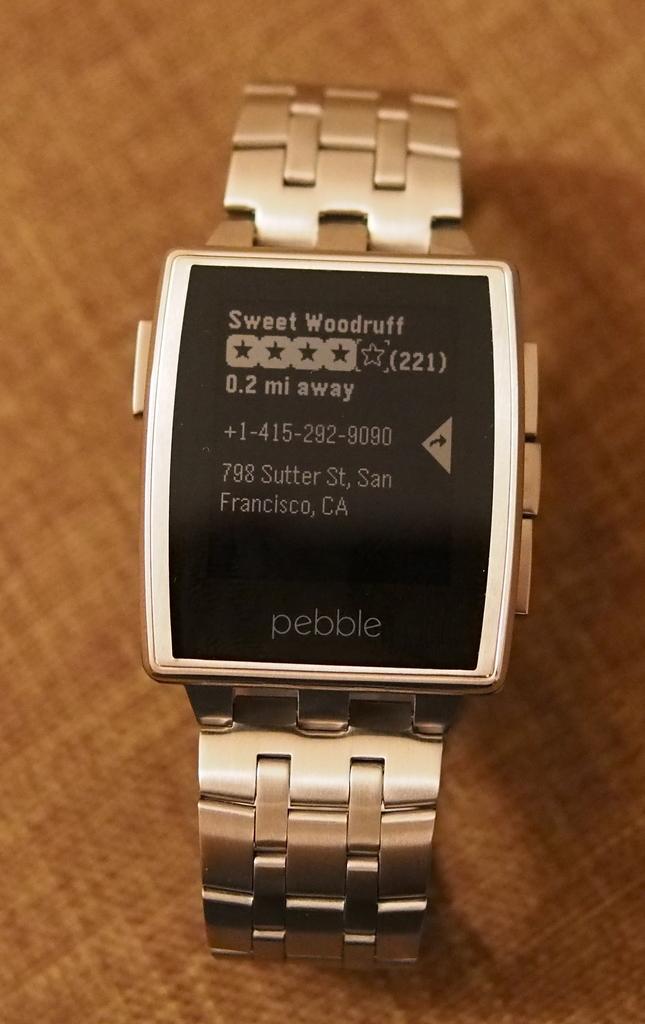What city is the message from?
Offer a very short reply. San francisco. What brand is the smartwatch?
Give a very brief answer. Pebble. 